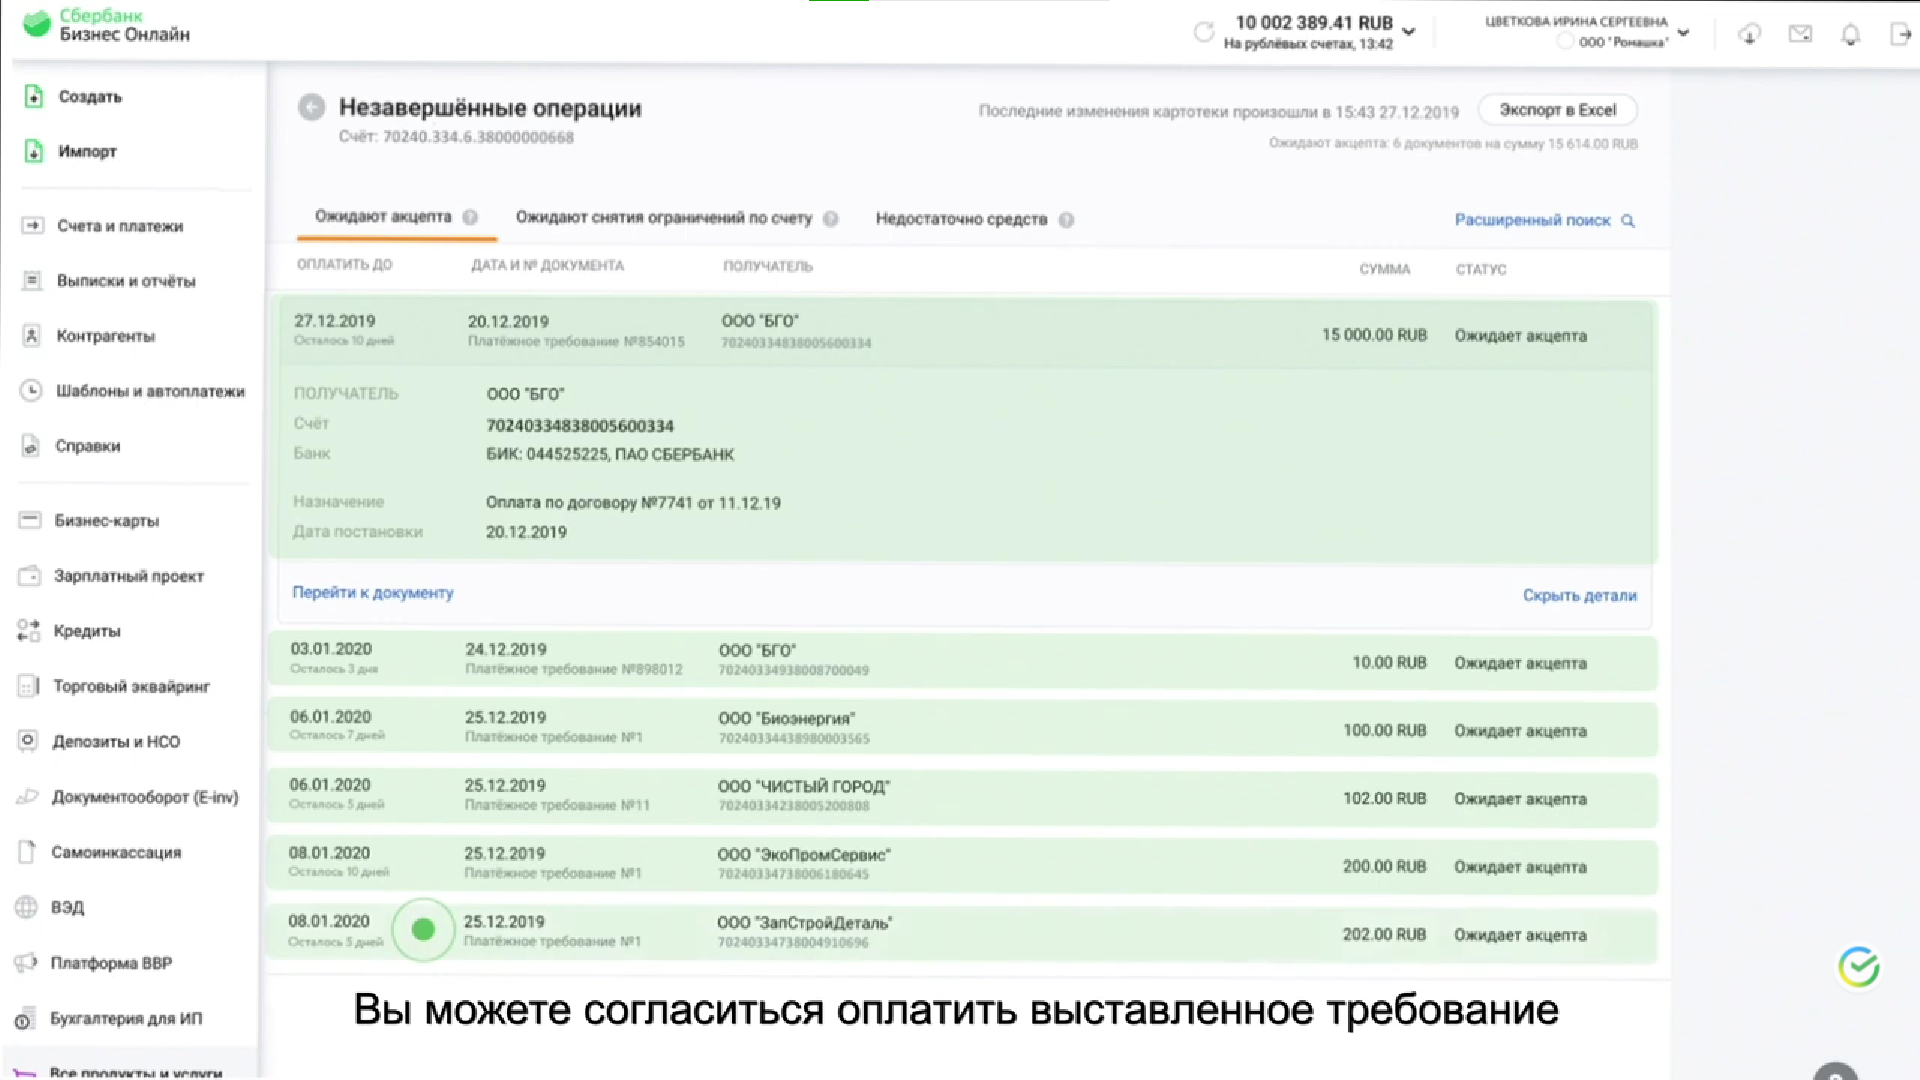Перечисли получателей незавершенных операций Вот получатели незавершенных операций:

1. ООО "БГО"
2. ООО "Биозенергия"
3. ООО "Чистый город"
4. ООО "ЭкоПромСервис"
5. ООО "ЗатСтройДеталь" Сколько незавершенных платежей, где получатель ООО "БГО"? На изображении показано 2 незавершенных платежа с получателем ООО "БГО". Сколько незавершенных платежей на сумму больше 15000 рублей? На изображении показан один незавершенный платеж на сумму больше 15,000 рублей. Сколько незавершенных платежей на сумму меньше 15000 рублей? На изображении показано шесть незавершенных платежей на сумму меньше 15,000 рублей. Сколько незавершенных платежей на сумму меньше 16000 рублей? На изображении показано шесть незавершенных платежей на сумму меньше 16,000 рублей. Кто владелец счета? Владельцем счета является Цветкова Ирина Сергеевна. 